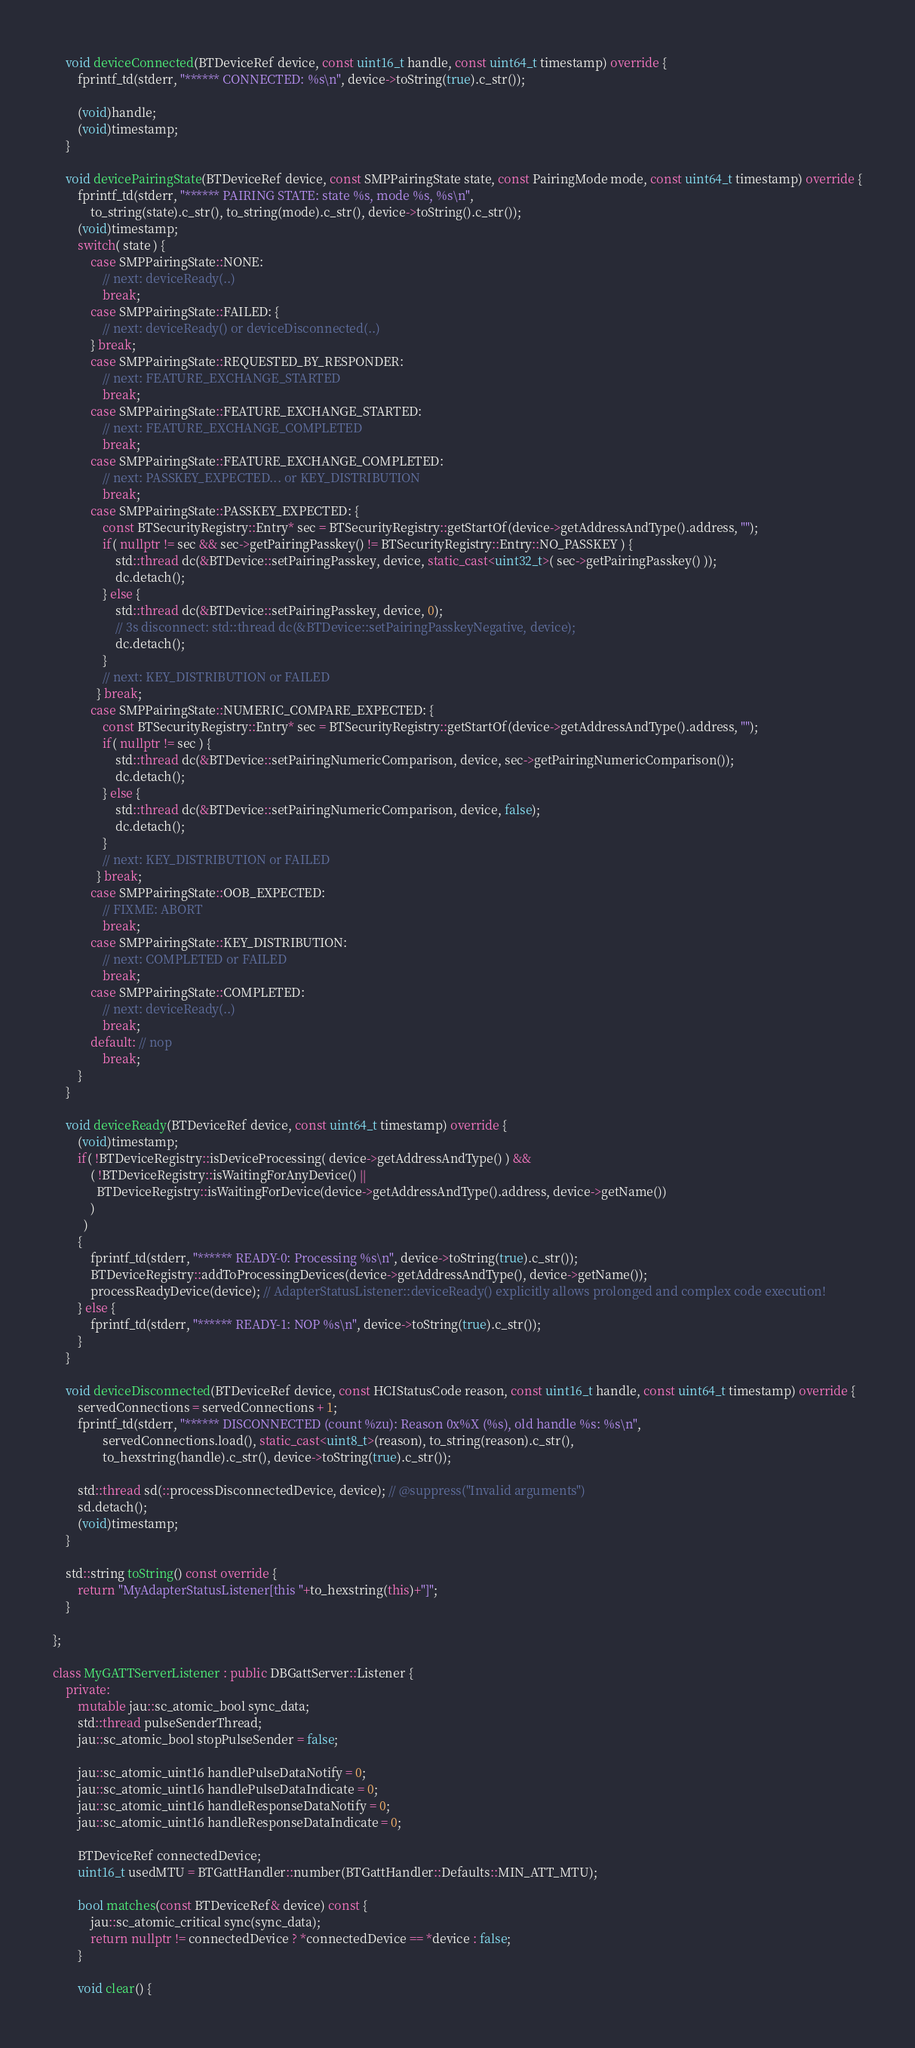<code> <loc_0><loc_0><loc_500><loc_500><_C++_>
    void deviceConnected(BTDeviceRef device, const uint16_t handle, const uint64_t timestamp) override {
        fprintf_td(stderr, "****** CONNECTED: %s\n", device->toString(true).c_str());

        (void)handle;
        (void)timestamp;
    }

    void devicePairingState(BTDeviceRef device, const SMPPairingState state, const PairingMode mode, const uint64_t timestamp) override {
        fprintf_td(stderr, "****** PAIRING STATE: state %s, mode %s, %s\n",
            to_string(state).c_str(), to_string(mode).c_str(), device->toString().c_str());
        (void)timestamp;
        switch( state ) {
            case SMPPairingState::NONE:
                // next: deviceReady(..)
                break;
            case SMPPairingState::FAILED: {
                // next: deviceReady() or deviceDisconnected(..)
            } break;
            case SMPPairingState::REQUESTED_BY_RESPONDER:
                // next: FEATURE_EXCHANGE_STARTED
                break;
            case SMPPairingState::FEATURE_EXCHANGE_STARTED:
                // next: FEATURE_EXCHANGE_COMPLETED
                break;
            case SMPPairingState::FEATURE_EXCHANGE_COMPLETED:
                // next: PASSKEY_EXPECTED... or KEY_DISTRIBUTION
                break;
            case SMPPairingState::PASSKEY_EXPECTED: {
                const BTSecurityRegistry::Entry* sec = BTSecurityRegistry::getStartOf(device->getAddressAndType().address, "");
                if( nullptr != sec && sec->getPairingPasskey() != BTSecurityRegistry::Entry::NO_PASSKEY ) {
                    std::thread dc(&BTDevice::setPairingPasskey, device, static_cast<uint32_t>( sec->getPairingPasskey() ));
                    dc.detach();
                } else {
                    std::thread dc(&BTDevice::setPairingPasskey, device, 0);
                    // 3s disconnect: std::thread dc(&BTDevice::setPairingPasskeyNegative, device);
                    dc.detach();
                }
                // next: KEY_DISTRIBUTION or FAILED
              } break;
            case SMPPairingState::NUMERIC_COMPARE_EXPECTED: {
                const BTSecurityRegistry::Entry* sec = BTSecurityRegistry::getStartOf(device->getAddressAndType().address, "");
                if( nullptr != sec ) {
                    std::thread dc(&BTDevice::setPairingNumericComparison, device, sec->getPairingNumericComparison());
                    dc.detach();
                } else {
                    std::thread dc(&BTDevice::setPairingNumericComparison, device, false);
                    dc.detach();
                }
                // next: KEY_DISTRIBUTION or FAILED
              } break;
            case SMPPairingState::OOB_EXPECTED:
                // FIXME: ABORT
                break;
            case SMPPairingState::KEY_DISTRIBUTION:
                // next: COMPLETED or FAILED
                break;
            case SMPPairingState::COMPLETED:
                // next: deviceReady(..)
                break;
            default: // nop
                break;
        }
    }

    void deviceReady(BTDeviceRef device, const uint64_t timestamp) override {
        (void)timestamp;
        if( !BTDeviceRegistry::isDeviceProcessing( device->getAddressAndType() ) &&
            ( !BTDeviceRegistry::isWaitingForAnyDevice() ||
              BTDeviceRegistry::isWaitingForDevice(device->getAddressAndType().address, device->getName())
            )
          )
        {
            fprintf_td(stderr, "****** READY-0: Processing %s\n", device->toString(true).c_str());
            BTDeviceRegistry::addToProcessingDevices(device->getAddressAndType(), device->getName());
            processReadyDevice(device); // AdapterStatusListener::deviceReady() explicitly allows prolonged and complex code execution!
        } else {
            fprintf_td(stderr, "****** READY-1: NOP %s\n", device->toString(true).c_str());
        }
    }

    void deviceDisconnected(BTDeviceRef device, const HCIStatusCode reason, const uint16_t handle, const uint64_t timestamp) override {
        servedConnections = servedConnections + 1;
        fprintf_td(stderr, "****** DISCONNECTED (count %zu): Reason 0x%X (%s), old handle %s: %s\n",
                servedConnections.load(), static_cast<uint8_t>(reason), to_string(reason).c_str(),
                to_hexstring(handle).c_str(), device->toString(true).c_str());

        std::thread sd(::processDisconnectedDevice, device); // @suppress("Invalid arguments")
        sd.detach();
        (void)timestamp;
    }

    std::string toString() const override {
        return "MyAdapterStatusListener[this "+to_hexstring(this)+"]";
    }

};

class MyGATTServerListener : public DBGattServer::Listener {
    private:
        mutable jau::sc_atomic_bool sync_data;
        std::thread pulseSenderThread;
        jau::sc_atomic_bool stopPulseSender = false;

        jau::sc_atomic_uint16 handlePulseDataNotify = 0;
        jau::sc_atomic_uint16 handlePulseDataIndicate = 0;
        jau::sc_atomic_uint16 handleResponseDataNotify = 0;
        jau::sc_atomic_uint16 handleResponseDataIndicate = 0;

        BTDeviceRef connectedDevice;
        uint16_t usedMTU = BTGattHandler::number(BTGattHandler::Defaults::MIN_ATT_MTU);

        bool matches(const BTDeviceRef& device) const {
            jau::sc_atomic_critical sync(sync_data);
            return nullptr != connectedDevice ? *connectedDevice == *device : false;
        }

        void clear() {</code> 